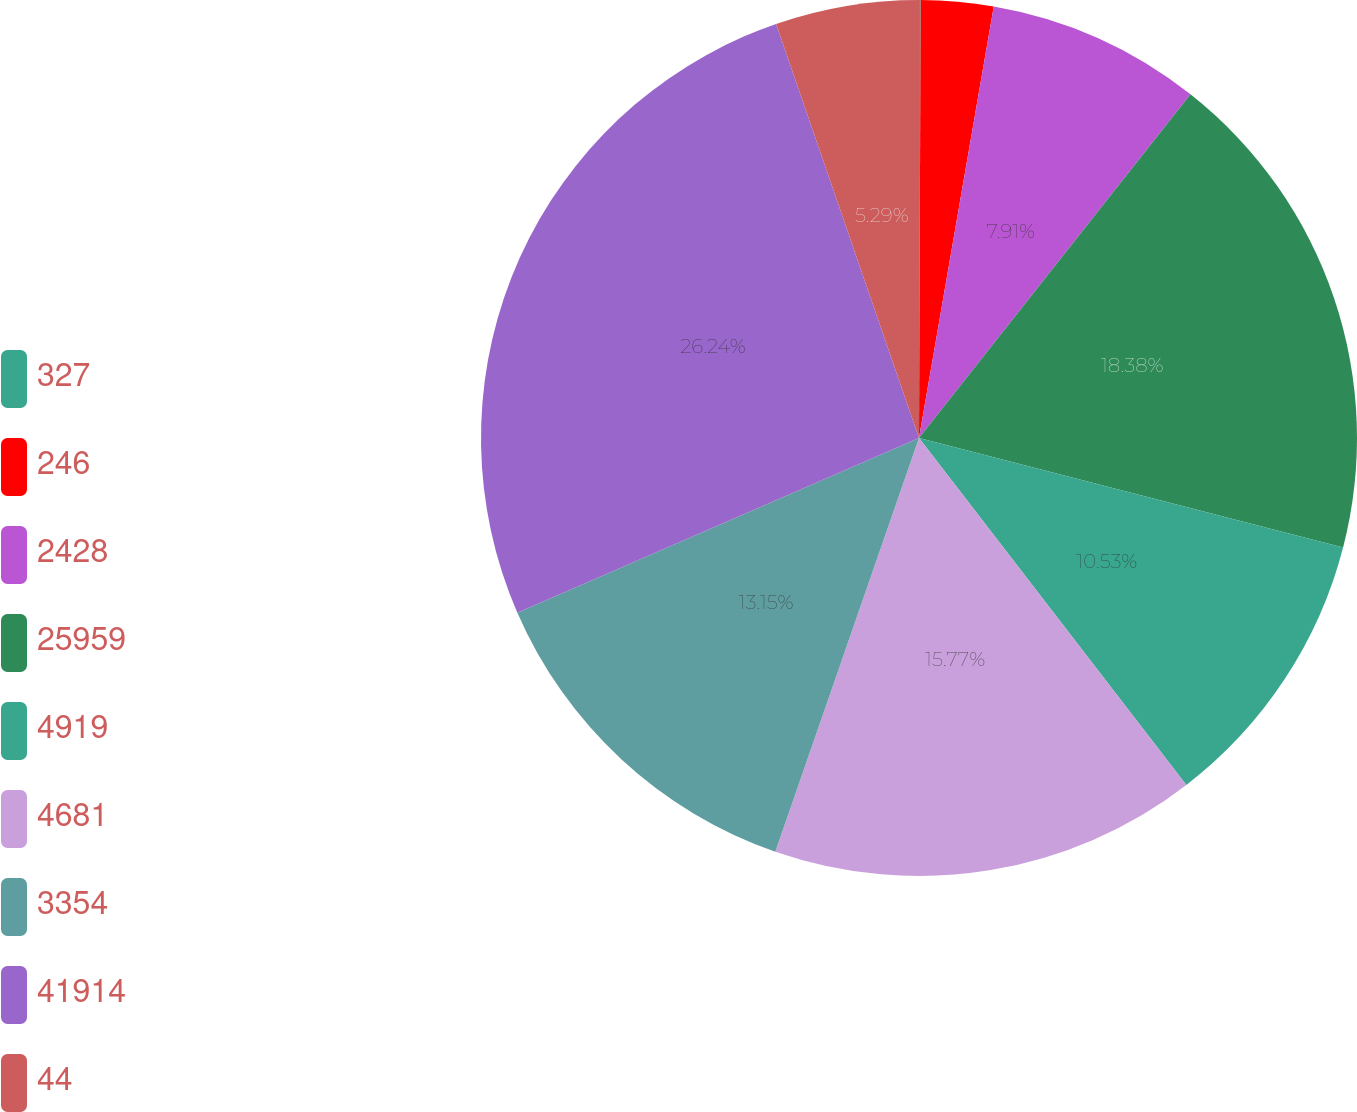<chart> <loc_0><loc_0><loc_500><loc_500><pie_chart><fcel>327<fcel>246<fcel>2428<fcel>25959<fcel>4919<fcel>4681<fcel>3354<fcel>41914<fcel>44<nl><fcel>0.06%<fcel>2.67%<fcel>7.91%<fcel>18.38%<fcel>10.53%<fcel>15.77%<fcel>13.15%<fcel>26.24%<fcel>5.29%<nl></chart> 